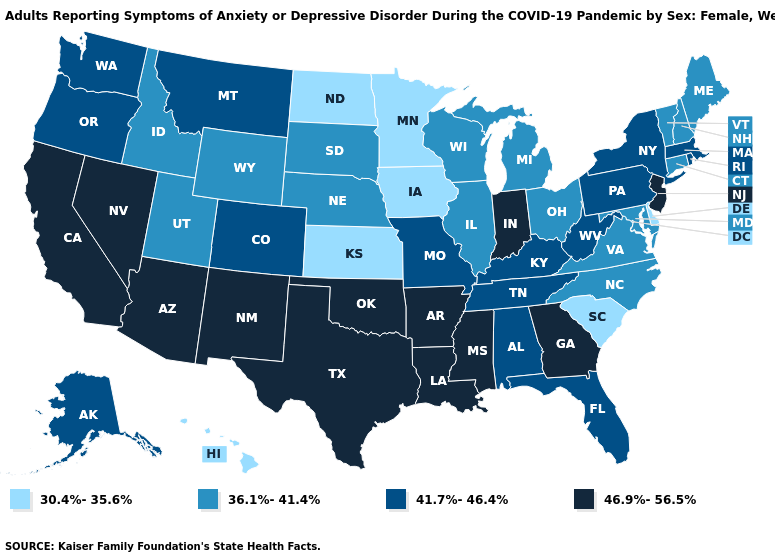Does Nebraska have a higher value than North Dakota?
Concise answer only. Yes. Does Missouri have the highest value in the USA?
Keep it brief. No. What is the value of Colorado?
Short answer required. 41.7%-46.4%. What is the value of Illinois?
Give a very brief answer. 36.1%-41.4%. Among the states that border Illinois , does Iowa have the lowest value?
Write a very short answer. Yes. Is the legend a continuous bar?
Give a very brief answer. No. What is the value of Wyoming?
Answer briefly. 36.1%-41.4%. What is the value of Ohio?
Write a very short answer. 36.1%-41.4%. Among the states that border Illinois , which have the highest value?
Concise answer only. Indiana. Among the states that border Vermont , which have the lowest value?
Concise answer only. New Hampshire. Name the states that have a value in the range 30.4%-35.6%?
Keep it brief. Delaware, Hawaii, Iowa, Kansas, Minnesota, North Dakota, South Carolina. Name the states that have a value in the range 46.9%-56.5%?
Give a very brief answer. Arizona, Arkansas, California, Georgia, Indiana, Louisiana, Mississippi, Nevada, New Jersey, New Mexico, Oklahoma, Texas. Does Texas have a higher value than Mississippi?
Short answer required. No. What is the lowest value in the USA?
Short answer required. 30.4%-35.6%. What is the value of Colorado?
Concise answer only. 41.7%-46.4%. 